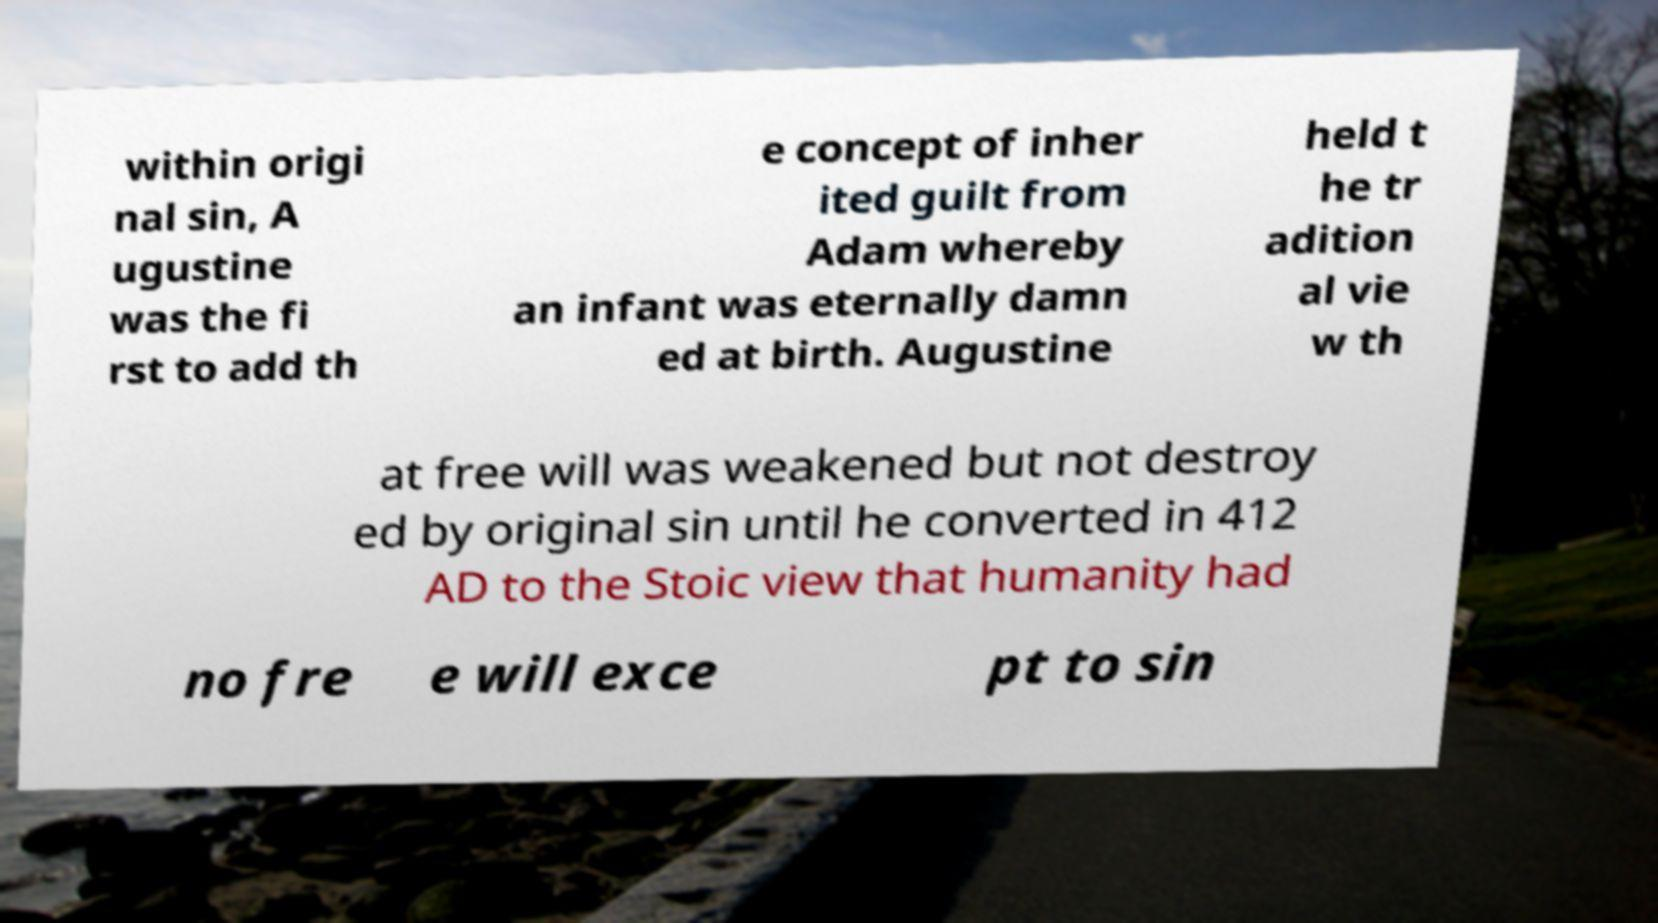I need the written content from this picture converted into text. Can you do that? within origi nal sin, A ugustine was the fi rst to add th e concept of inher ited guilt from Adam whereby an infant was eternally damn ed at birth. Augustine held t he tr adition al vie w th at free will was weakened but not destroy ed by original sin until he converted in 412 AD to the Stoic view that humanity had no fre e will exce pt to sin 